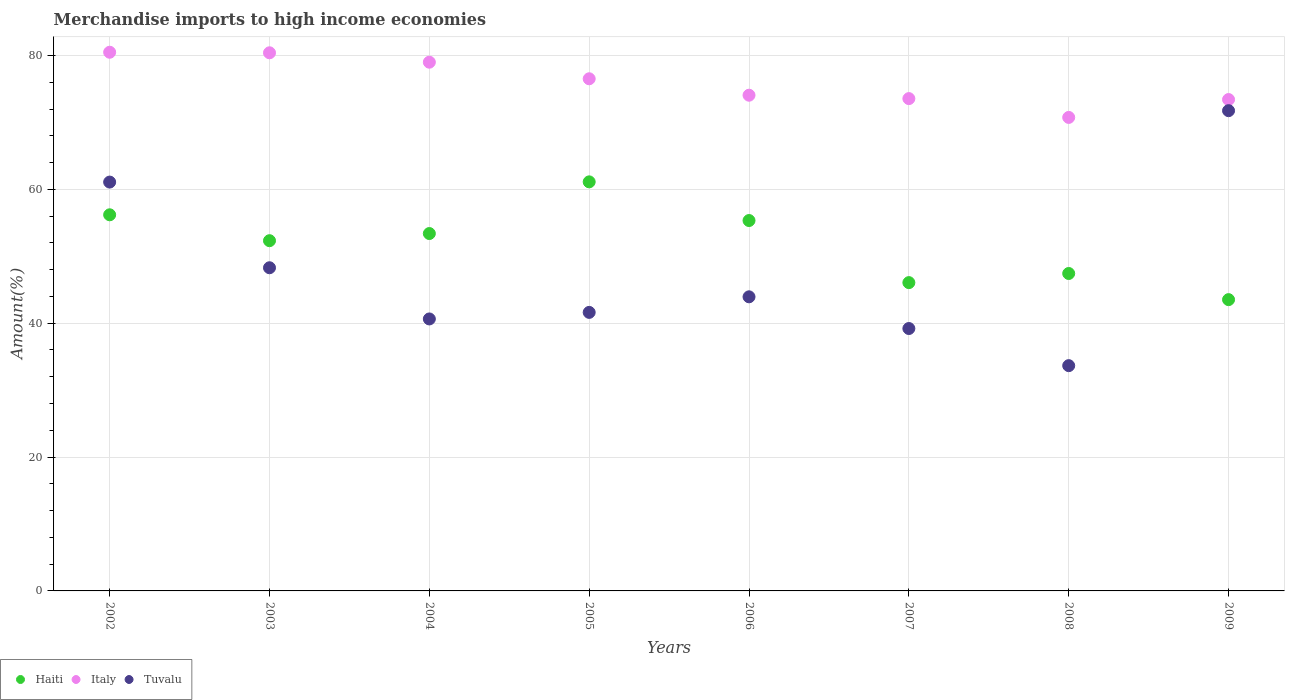What is the percentage of amount earned from merchandise imports in Italy in 2008?
Keep it short and to the point. 70.74. Across all years, what is the maximum percentage of amount earned from merchandise imports in Tuvalu?
Offer a terse response. 71.75. Across all years, what is the minimum percentage of amount earned from merchandise imports in Haiti?
Provide a succinct answer. 43.52. What is the total percentage of amount earned from merchandise imports in Haiti in the graph?
Offer a terse response. 415.37. What is the difference between the percentage of amount earned from merchandise imports in Italy in 2006 and that in 2009?
Your answer should be very brief. 0.65. What is the difference between the percentage of amount earned from merchandise imports in Haiti in 2006 and the percentage of amount earned from merchandise imports in Italy in 2007?
Keep it short and to the point. -18.22. What is the average percentage of amount earned from merchandise imports in Haiti per year?
Your answer should be very brief. 51.92. In the year 2009, what is the difference between the percentage of amount earned from merchandise imports in Tuvalu and percentage of amount earned from merchandise imports in Italy?
Give a very brief answer. -1.67. In how many years, is the percentage of amount earned from merchandise imports in Tuvalu greater than 12 %?
Offer a very short reply. 8. What is the ratio of the percentage of amount earned from merchandise imports in Haiti in 2002 to that in 2004?
Make the answer very short. 1.05. What is the difference between the highest and the second highest percentage of amount earned from merchandise imports in Italy?
Keep it short and to the point. 0.08. What is the difference between the highest and the lowest percentage of amount earned from merchandise imports in Haiti?
Your answer should be very brief. 17.6. In how many years, is the percentage of amount earned from merchandise imports in Italy greater than the average percentage of amount earned from merchandise imports in Italy taken over all years?
Provide a short and direct response. 4. Is it the case that in every year, the sum of the percentage of amount earned from merchandise imports in Haiti and percentage of amount earned from merchandise imports in Tuvalu  is greater than the percentage of amount earned from merchandise imports in Italy?
Keep it short and to the point. Yes. Does the percentage of amount earned from merchandise imports in Haiti monotonically increase over the years?
Your response must be concise. No. Is the percentage of amount earned from merchandise imports in Italy strictly less than the percentage of amount earned from merchandise imports in Tuvalu over the years?
Ensure brevity in your answer.  No. What is the difference between two consecutive major ticks on the Y-axis?
Your response must be concise. 20. Are the values on the major ticks of Y-axis written in scientific E-notation?
Your answer should be compact. No. Does the graph contain any zero values?
Your response must be concise. No. Does the graph contain grids?
Offer a terse response. Yes. Where does the legend appear in the graph?
Your response must be concise. Bottom left. How many legend labels are there?
Your response must be concise. 3. What is the title of the graph?
Your answer should be compact. Merchandise imports to high income economies. What is the label or title of the X-axis?
Ensure brevity in your answer.  Years. What is the label or title of the Y-axis?
Your answer should be very brief. Amount(%). What is the Amount(%) of Haiti in 2002?
Offer a very short reply. 56.19. What is the Amount(%) in Italy in 2002?
Give a very brief answer. 80.48. What is the Amount(%) of Tuvalu in 2002?
Give a very brief answer. 61.08. What is the Amount(%) of Haiti in 2003?
Your response must be concise. 52.32. What is the Amount(%) of Italy in 2003?
Keep it short and to the point. 80.4. What is the Amount(%) in Tuvalu in 2003?
Provide a succinct answer. 48.28. What is the Amount(%) in Haiti in 2004?
Provide a succinct answer. 53.39. What is the Amount(%) in Italy in 2004?
Provide a short and direct response. 78.99. What is the Amount(%) of Tuvalu in 2004?
Make the answer very short. 40.63. What is the Amount(%) of Haiti in 2005?
Provide a short and direct response. 61.12. What is the Amount(%) in Italy in 2005?
Make the answer very short. 76.52. What is the Amount(%) of Tuvalu in 2005?
Keep it short and to the point. 41.61. What is the Amount(%) of Haiti in 2006?
Ensure brevity in your answer.  55.34. What is the Amount(%) in Italy in 2006?
Your answer should be compact. 74.06. What is the Amount(%) of Tuvalu in 2006?
Provide a short and direct response. 43.94. What is the Amount(%) of Haiti in 2007?
Your response must be concise. 46.06. What is the Amount(%) of Italy in 2007?
Keep it short and to the point. 73.55. What is the Amount(%) of Tuvalu in 2007?
Ensure brevity in your answer.  39.2. What is the Amount(%) of Haiti in 2008?
Provide a succinct answer. 47.43. What is the Amount(%) of Italy in 2008?
Keep it short and to the point. 70.74. What is the Amount(%) of Tuvalu in 2008?
Your response must be concise. 33.66. What is the Amount(%) of Haiti in 2009?
Offer a terse response. 43.52. What is the Amount(%) in Italy in 2009?
Provide a succinct answer. 73.41. What is the Amount(%) in Tuvalu in 2009?
Your answer should be compact. 71.75. Across all years, what is the maximum Amount(%) of Haiti?
Offer a terse response. 61.12. Across all years, what is the maximum Amount(%) in Italy?
Ensure brevity in your answer.  80.48. Across all years, what is the maximum Amount(%) in Tuvalu?
Give a very brief answer. 71.75. Across all years, what is the minimum Amount(%) of Haiti?
Make the answer very short. 43.52. Across all years, what is the minimum Amount(%) of Italy?
Keep it short and to the point. 70.74. Across all years, what is the minimum Amount(%) in Tuvalu?
Your response must be concise. 33.66. What is the total Amount(%) in Haiti in the graph?
Make the answer very short. 415.37. What is the total Amount(%) in Italy in the graph?
Keep it short and to the point. 608.16. What is the total Amount(%) of Tuvalu in the graph?
Provide a short and direct response. 380.16. What is the difference between the Amount(%) in Haiti in 2002 and that in 2003?
Keep it short and to the point. 3.87. What is the difference between the Amount(%) in Italy in 2002 and that in 2003?
Make the answer very short. 0.08. What is the difference between the Amount(%) of Tuvalu in 2002 and that in 2003?
Provide a succinct answer. 12.8. What is the difference between the Amount(%) of Haiti in 2002 and that in 2004?
Provide a short and direct response. 2.8. What is the difference between the Amount(%) of Italy in 2002 and that in 2004?
Offer a very short reply. 1.49. What is the difference between the Amount(%) of Tuvalu in 2002 and that in 2004?
Offer a very short reply. 20.45. What is the difference between the Amount(%) in Haiti in 2002 and that in 2005?
Offer a very short reply. -4.92. What is the difference between the Amount(%) of Italy in 2002 and that in 2005?
Ensure brevity in your answer.  3.96. What is the difference between the Amount(%) in Tuvalu in 2002 and that in 2005?
Your response must be concise. 19.47. What is the difference between the Amount(%) of Haiti in 2002 and that in 2006?
Ensure brevity in your answer.  0.86. What is the difference between the Amount(%) of Italy in 2002 and that in 2006?
Your answer should be compact. 6.42. What is the difference between the Amount(%) of Tuvalu in 2002 and that in 2006?
Give a very brief answer. 17.14. What is the difference between the Amount(%) of Haiti in 2002 and that in 2007?
Your answer should be very brief. 10.13. What is the difference between the Amount(%) in Italy in 2002 and that in 2007?
Your answer should be very brief. 6.93. What is the difference between the Amount(%) in Tuvalu in 2002 and that in 2007?
Offer a very short reply. 21.88. What is the difference between the Amount(%) of Haiti in 2002 and that in 2008?
Offer a very short reply. 8.77. What is the difference between the Amount(%) in Italy in 2002 and that in 2008?
Offer a terse response. 9.74. What is the difference between the Amount(%) of Tuvalu in 2002 and that in 2008?
Give a very brief answer. 27.43. What is the difference between the Amount(%) in Haiti in 2002 and that in 2009?
Offer a very short reply. 12.68. What is the difference between the Amount(%) in Italy in 2002 and that in 2009?
Make the answer very short. 7.06. What is the difference between the Amount(%) of Tuvalu in 2002 and that in 2009?
Give a very brief answer. -10.67. What is the difference between the Amount(%) in Haiti in 2003 and that in 2004?
Provide a short and direct response. -1.07. What is the difference between the Amount(%) of Italy in 2003 and that in 2004?
Offer a very short reply. 1.4. What is the difference between the Amount(%) of Tuvalu in 2003 and that in 2004?
Your response must be concise. 7.65. What is the difference between the Amount(%) in Haiti in 2003 and that in 2005?
Make the answer very short. -8.79. What is the difference between the Amount(%) of Italy in 2003 and that in 2005?
Ensure brevity in your answer.  3.88. What is the difference between the Amount(%) in Tuvalu in 2003 and that in 2005?
Keep it short and to the point. 6.67. What is the difference between the Amount(%) in Haiti in 2003 and that in 2006?
Give a very brief answer. -3.01. What is the difference between the Amount(%) of Italy in 2003 and that in 2006?
Your response must be concise. 6.34. What is the difference between the Amount(%) in Tuvalu in 2003 and that in 2006?
Your answer should be compact. 4.34. What is the difference between the Amount(%) of Haiti in 2003 and that in 2007?
Your answer should be compact. 6.26. What is the difference between the Amount(%) of Italy in 2003 and that in 2007?
Offer a very short reply. 6.84. What is the difference between the Amount(%) in Tuvalu in 2003 and that in 2007?
Offer a terse response. 9.08. What is the difference between the Amount(%) in Haiti in 2003 and that in 2008?
Your response must be concise. 4.9. What is the difference between the Amount(%) of Italy in 2003 and that in 2008?
Offer a very short reply. 9.66. What is the difference between the Amount(%) of Tuvalu in 2003 and that in 2008?
Your response must be concise. 14.63. What is the difference between the Amount(%) in Haiti in 2003 and that in 2009?
Keep it short and to the point. 8.81. What is the difference between the Amount(%) of Italy in 2003 and that in 2009?
Provide a short and direct response. 6.98. What is the difference between the Amount(%) in Tuvalu in 2003 and that in 2009?
Ensure brevity in your answer.  -23.47. What is the difference between the Amount(%) of Haiti in 2004 and that in 2005?
Make the answer very short. -7.72. What is the difference between the Amount(%) in Italy in 2004 and that in 2005?
Make the answer very short. 2.48. What is the difference between the Amount(%) of Tuvalu in 2004 and that in 2005?
Provide a short and direct response. -0.98. What is the difference between the Amount(%) of Haiti in 2004 and that in 2006?
Your answer should be compact. -1.94. What is the difference between the Amount(%) of Italy in 2004 and that in 2006?
Give a very brief answer. 4.93. What is the difference between the Amount(%) in Tuvalu in 2004 and that in 2006?
Your response must be concise. -3.31. What is the difference between the Amount(%) of Haiti in 2004 and that in 2007?
Your answer should be compact. 7.33. What is the difference between the Amount(%) in Italy in 2004 and that in 2007?
Give a very brief answer. 5.44. What is the difference between the Amount(%) of Tuvalu in 2004 and that in 2007?
Give a very brief answer. 1.43. What is the difference between the Amount(%) of Haiti in 2004 and that in 2008?
Keep it short and to the point. 5.97. What is the difference between the Amount(%) of Italy in 2004 and that in 2008?
Provide a short and direct response. 8.25. What is the difference between the Amount(%) of Tuvalu in 2004 and that in 2008?
Your response must be concise. 6.98. What is the difference between the Amount(%) of Haiti in 2004 and that in 2009?
Offer a terse response. 9.88. What is the difference between the Amount(%) of Italy in 2004 and that in 2009?
Offer a terse response. 5.58. What is the difference between the Amount(%) of Tuvalu in 2004 and that in 2009?
Offer a very short reply. -31.11. What is the difference between the Amount(%) in Haiti in 2005 and that in 2006?
Give a very brief answer. 5.78. What is the difference between the Amount(%) in Italy in 2005 and that in 2006?
Your answer should be very brief. 2.45. What is the difference between the Amount(%) in Tuvalu in 2005 and that in 2006?
Your answer should be compact. -2.33. What is the difference between the Amount(%) in Haiti in 2005 and that in 2007?
Offer a very short reply. 15.05. What is the difference between the Amount(%) of Italy in 2005 and that in 2007?
Provide a succinct answer. 2.96. What is the difference between the Amount(%) of Tuvalu in 2005 and that in 2007?
Offer a very short reply. 2.41. What is the difference between the Amount(%) of Haiti in 2005 and that in 2008?
Your answer should be very brief. 13.69. What is the difference between the Amount(%) of Italy in 2005 and that in 2008?
Your answer should be very brief. 5.77. What is the difference between the Amount(%) of Tuvalu in 2005 and that in 2008?
Your answer should be compact. 7.96. What is the difference between the Amount(%) of Haiti in 2005 and that in 2009?
Your response must be concise. 17.6. What is the difference between the Amount(%) of Italy in 2005 and that in 2009?
Your answer should be compact. 3.1. What is the difference between the Amount(%) of Tuvalu in 2005 and that in 2009?
Your answer should be very brief. -30.14. What is the difference between the Amount(%) of Haiti in 2006 and that in 2007?
Give a very brief answer. 9.28. What is the difference between the Amount(%) in Italy in 2006 and that in 2007?
Provide a succinct answer. 0.51. What is the difference between the Amount(%) in Tuvalu in 2006 and that in 2007?
Offer a very short reply. 4.74. What is the difference between the Amount(%) of Haiti in 2006 and that in 2008?
Ensure brevity in your answer.  7.91. What is the difference between the Amount(%) in Italy in 2006 and that in 2008?
Ensure brevity in your answer.  3.32. What is the difference between the Amount(%) of Tuvalu in 2006 and that in 2008?
Provide a succinct answer. 10.28. What is the difference between the Amount(%) in Haiti in 2006 and that in 2009?
Your response must be concise. 11.82. What is the difference between the Amount(%) in Italy in 2006 and that in 2009?
Make the answer very short. 0.65. What is the difference between the Amount(%) of Tuvalu in 2006 and that in 2009?
Your answer should be very brief. -27.81. What is the difference between the Amount(%) in Haiti in 2007 and that in 2008?
Keep it short and to the point. -1.36. What is the difference between the Amount(%) in Italy in 2007 and that in 2008?
Provide a succinct answer. 2.81. What is the difference between the Amount(%) of Tuvalu in 2007 and that in 2008?
Give a very brief answer. 5.55. What is the difference between the Amount(%) of Haiti in 2007 and that in 2009?
Give a very brief answer. 2.54. What is the difference between the Amount(%) in Italy in 2007 and that in 2009?
Your answer should be compact. 0.14. What is the difference between the Amount(%) of Tuvalu in 2007 and that in 2009?
Provide a succinct answer. -32.55. What is the difference between the Amount(%) of Haiti in 2008 and that in 2009?
Offer a terse response. 3.91. What is the difference between the Amount(%) of Italy in 2008 and that in 2009?
Your answer should be very brief. -2.67. What is the difference between the Amount(%) of Tuvalu in 2008 and that in 2009?
Provide a succinct answer. -38.09. What is the difference between the Amount(%) of Haiti in 2002 and the Amount(%) of Italy in 2003?
Ensure brevity in your answer.  -24.2. What is the difference between the Amount(%) in Haiti in 2002 and the Amount(%) in Tuvalu in 2003?
Provide a succinct answer. 7.91. What is the difference between the Amount(%) in Italy in 2002 and the Amount(%) in Tuvalu in 2003?
Give a very brief answer. 32.2. What is the difference between the Amount(%) of Haiti in 2002 and the Amount(%) of Italy in 2004?
Your response must be concise. -22.8. What is the difference between the Amount(%) in Haiti in 2002 and the Amount(%) in Tuvalu in 2004?
Ensure brevity in your answer.  15.56. What is the difference between the Amount(%) of Italy in 2002 and the Amount(%) of Tuvalu in 2004?
Make the answer very short. 39.85. What is the difference between the Amount(%) in Haiti in 2002 and the Amount(%) in Italy in 2005?
Your response must be concise. -20.32. What is the difference between the Amount(%) of Haiti in 2002 and the Amount(%) of Tuvalu in 2005?
Provide a succinct answer. 14.58. What is the difference between the Amount(%) of Italy in 2002 and the Amount(%) of Tuvalu in 2005?
Your answer should be compact. 38.87. What is the difference between the Amount(%) in Haiti in 2002 and the Amount(%) in Italy in 2006?
Your answer should be compact. -17.87. What is the difference between the Amount(%) in Haiti in 2002 and the Amount(%) in Tuvalu in 2006?
Your response must be concise. 12.25. What is the difference between the Amount(%) of Italy in 2002 and the Amount(%) of Tuvalu in 2006?
Your answer should be compact. 36.54. What is the difference between the Amount(%) in Haiti in 2002 and the Amount(%) in Italy in 2007?
Your response must be concise. -17.36. What is the difference between the Amount(%) in Haiti in 2002 and the Amount(%) in Tuvalu in 2007?
Your answer should be compact. 16.99. What is the difference between the Amount(%) of Italy in 2002 and the Amount(%) of Tuvalu in 2007?
Your response must be concise. 41.28. What is the difference between the Amount(%) in Haiti in 2002 and the Amount(%) in Italy in 2008?
Your answer should be very brief. -14.55. What is the difference between the Amount(%) in Haiti in 2002 and the Amount(%) in Tuvalu in 2008?
Your response must be concise. 22.54. What is the difference between the Amount(%) in Italy in 2002 and the Amount(%) in Tuvalu in 2008?
Ensure brevity in your answer.  46.82. What is the difference between the Amount(%) of Haiti in 2002 and the Amount(%) of Italy in 2009?
Offer a terse response. -17.22. What is the difference between the Amount(%) in Haiti in 2002 and the Amount(%) in Tuvalu in 2009?
Your answer should be very brief. -15.56. What is the difference between the Amount(%) in Italy in 2002 and the Amount(%) in Tuvalu in 2009?
Provide a succinct answer. 8.73. What is the difference between the Amount(%) in Haiti in 2003 and the Amount(%) in Italy in 2004?
Give a very brief answer. -26.67. What is the difference between the Amount(%) in Haiti in 2003 and the Amount(%) in Tuvalu in 2004?
Give a very brief answer. 11.69. What is the difference between the Amount(%) in Italy in 2003 and the Amount(%) in Tuvalu in 2004?
Provide a succinct answer. 39.76. What is the difference between the Amount(%) of Haiti in 2003 and the Amount(%) of Italy in 2005?
Keep it short and to the point. -24.19. What is the difference between the Amount(%) of Haiti in 2003 and the Amount(%) of Tuvalu in 2005?
Give a very brief answer. 10.71. What is the difference between the Amount(%) in Italy in 2003 and the Amount(%) in Tuvalu in 2005?
Ensure brevity in your answer.  38.78. What is the difference between the Amount(%) in Haiti in 2003 and the Amount(%) in Italy in 2006?
Ensure brevity in your answer.  -21.74. What is the difference between the Amount(%) of Haiti in 2003 and the Amount(%) of Tuvalu in 2006?
Your response must be concise. 8.39. What is the difference between the Amount(%) of Italy in 2003 and the Amount(%) of Tuvalu in 2006?
Your response must be concise. 36.46. What is the difference between the Amount(%) of Haiti in 2003 and the Amount(%) of Italy in 2007?
Provide a short and direct response. -21.23. What is the difference between the Amount(%) of Haiti in 2003 and the Amount(%) of Tuvalu in 2007?
Offer a terse response. 13.12. What is the difference between the Amount(%) in Italy in 2003 and the Amount(%) in Tuvalu in 2007?
Offer a terse response. 41.19. What is the difference between the Amount(%) in Haiti in 2003 and the Amount(%) in Italy in 2008?
Your response must be concise. -18.42. What is the difference between the Amount(%) of Haiti in 2003 and the Amount(%) of Tuvalu in 2008?
Provide a short and direct response. 18.67. What is the difference between the Amount(%) of Italy in 2003 and the Amount(%) of Tuvalu in 2008?
Offer a terse response. 46.74. What is the difference between the Amount(%) of Haiti in 2003 and the Amount(%) of Italy in 2009?
Make the answer very short. -21.09. What is the difference between the Amount(%) of Haiti in 2003 and the Amount(%) of Tuvalu in 2009?
Your response must be concise. -19.42. What is the difference between the Amount(%) in Italy in 2003 and the Amount(%) in Tuvalu in 2009?
Keep it short and to the point. 8.65. What is the difference between the Amount(%) of Haiti in 2004 and the Amount(%) of Italy in 2005?
Your answer should be compact. -23.12. What is the difference between the Amount(%) in Haiti in 2004 and the Amount(%) in Tuvalu in 2005?
Provide a succinct answer. 11.78. What is the difference between the Amount(%) in Italy in 2004 and the Amount(%) in Tuvalu in 2005?
Offer a very short reply. 37.38. What is the difference between the Amount(%) in Haiti in 2004 and the Amount(%) in Italy in 2006?
Offer a very short reply. -20.67. What is the difference between the Amount(%) in Haiti in 2004 and the Amount(%) in Tuvalu in 2006?
Make the answer very short. 9.45. What is the difference between the Amount(%) in Italy in 2004 and the Amount(%) in Tuvalu in 2006?
Provide a short and direct response. 35.05. What is the difference between the Amount(%) of Haiti in 2004 and the Amount(%) of Italy in 2007?
Ensure brevity in your answer.  -20.16. What is the difference between the Amount(%) in Haiti in 2004 and the Amount(%) in Tuvalu in 2007?
Provide a succinct answer. 14.19. What is the difference between the Amount(%) of Italy in 2004 and the Amount(%) of Tuvalu in 2007?
Give a very brief answer. 39.79. What is the difference between the Amount(%) of Haiti in 2004 and the Amount(%) of Italy in 2008?
Ensure brevity in your answer.  -17.35. What is the difference between the Amount(%) of Haiti in 2004 and the Amount(%) of Tuvalu in 2008?
Your response must be concise. 19.74. What is the difference between the Amount(%) in Italy in 2004 and the Amount(%) in Tuvalu in 2008?
Offer a terse response. 45.34. What is the difference between the Amount(%) of Haiti in 2004 and the Amount(%) of Italy in 2009?
Provide a short and direct response. -20.02. What is the difference between the Amount(%) in Haiti in 2004 and the Amount(%) in Tuvalu in 2009?
Provide a succinct answer. -18.36. What is the difference between the Amount(%) of Italy in 2004 and the Amount(%) of Tuvalu in 2009?
Make the answer very short. 7.24. What is the difference between the Amount(%) of Haiti in 2005 and the Amount(%) of Italy in 2006?
Provide a short and direct response. -12.95. What is the difference between the Amount(%) of Haiti in 2005 and the Amount(%) of Tuvalu in 2006?
Your answer should be compact. 17.18. What is the difference between the Amount(%) in Italy in 2005 and the Amount(%) in Tuvalu in 2006?
Make the answer very short. 32.58. What is the difference between the Amount(%) of Haiti in 2005 and the Amount(%) of Italy in 2007?
Provide a short and direct response. -12.44. What is the difference between the Amount(%) in Haiti in 2005 and the Amount(%) in Tuvalu in 2007?
Provide a short and direct response. 21.91. What is the difference between the Amount(%) in Italy in 2005 and the Amount(%) in Tuvalu in 2007?
Offer a very short reply. 37.31. What is the difference between the Amount(%) of Haiti in 2005 and the Amount(%) of Italy in 2008?
Your answer should be very brief. -9.63. What is the difference between the Amount(%) in Haiti in 2005 and the Amount(%) in Tuvalu in 2008?
Your answer should be compact. 27.46. What is the difference between the Amount(%) in Italy in 2005 and the Amount(%) in Tuvalu in 2008?
Make the answer very short. 42.86. What is the difference between the Amount(%) of Haiti in 2005 and the Amount(%) of Italy in 2009?
Keep it short and to the point. -12.3. What is the difference between the Amount(%) in Haiti in 2005 and the Amount(%) in Tuvalu in 2009?
Give a very brief answer. -10.63. What is the difference between the Amount(%) in Italy in 2005 and the Amount(%) in Tuvalu in 2009?
Keep it short and to the point. 4.77. What is the difference between the Amount(%) in Haiti in 2006 and the Amount(%) in Italy in 2007?
Your answer should be very brief. -18.22. What is the difference between the Amount(%) of Haiti in 2006 and the Amount(%) of Tuvalu in 2007?
Your answer should be very brief. 16.13. What is the difference between the Amount(%) of Italy in 2006 and the Amount(%) of Tuvalu in 2007?
Keep it short and to the point. 34.86. What is the difference between the Amount(%) of Haiti in 2006 and the Amount(%) of Italy in 2008?
Make the answer very short. -15.41. What is the difference between the Amount(%) in Haiti in 2006 and the Amount(%) in Tuvalu in 2008?
Your response must be concise. 21.68. What is the difference between the Amount(%) in Italy in 2006 and the Amount(%) in Tuvalu in 2008?
Make the answer very short. 40.4. What is the difference between the Amount(%) of Haiti in 2006 and the Amount(%) of Italy in 2009?
Keep it short and to the point. -18.08. What is the difference between the Amount(%) in Haiti in 2006 and the Amount(%) in Tuvalu in 2009?
Your response must be concise. -16.41. What is the difference between the Amount(%) in Italy in 2006 and the Amount(%) in Tuvalu in 2009?
Your answer should be compact. 2.31. What is the difference between the Amount(%) of Haiti in 2007 and the Amount(%) of Italy in 2008?
Give a very brief answer. -24.68. What is the difference between the Amount(%) in Haiti in 2007 and the Amount(%) in Tuvalu in 2008?
Make the answer very short. 12.41. What is the difference between the Amount(%) in Italy in 2007 and the Amount(%) in Tuvalu in 2008?
Your answer should be compact. 39.9. What is the difference between the Amount(%) of Haiti in 2007 and the Amount(%) of Italy in 2009?
Offer a very short reply. -27.35. What is the difference between the Amount(%) in Haiti in 2007 and the Amount(%) in Tuvalu in 2009?
Offer a very short reply. -25.69. What is the difference between the Amount(%) in Italy in 2007 and the Amount(%) in Tuvalu in 2009?
Provide a succinct answer. 1.8. What is the difference between the Amount(%) of Haiti in 2008 and the Amount(%) of Italy in 2009?
Your answer should be very brief. -25.99. What is the difference between the Amount(%) in Haiti in 2008 and the Amount(%) in Tuvalu in 2009?
Your answer should be compact. -24.32. What is the difference between the Amount(%) of Italy in 2008 and the Amount(%) of Tuvalu in 2009?
Ensure brevity in your answer.  -1.01. What is the average Amount(%) in Haiti per year?
Make the answer very short. 51.92. What is the average Amount(%) in Italy per year?
Ensure brevity in your answer.  76.02. What is the average Amount(%) of Tuvalu per year?
Ensure brevity in your answer.  47.52. In the year 2002, what is the difference between the Amount(%) in Haiti and Amount(%) in Italy?
Provide a succinct answer. -24.29. In the year 2002, what is the difference between the Amount(%) in Haiti and Amount(%) in Tuvalu?
Offer a very short reply. -4.89. In the year 2002, what is the difference between the Amount(%) of Italy and Amount(%) of Tuvalu?
Give a very brief answer. 19.4. In the year 2003, what is the difference between the Amount(%) of Haiti and Amount(%) of Italy?
Ensure brevity in your answer.  -28.07. In the year 2003, what is the difference between the Amount(%) of Haiti and Amount(%) of Tuvalu?
Your answer should be very brief. 4.04. In the year 2003, what is the difference between the Amount(%) of Italy and Amount(%) of Tuvalu?
Offer a very short reply. 32.12. In the year 2004, what is the difference between the Amount(%) of Haiti and Amount(%) of Italy?
Make the answer very short. -25.6. In the year 2004, what is the difference between the Amount(%) in Haiti and Amount(%) in Tuvalu?
Your answer should be very brief. 12.76. In the year 2004, what is the difference between the Amount(%) in Italy and Amount(%) in Tuvalu?
Give a very brief answer. 38.36. In the year 2005, what is the difference between the Amount(%) of Haiti and Amount(%) of Italy?
Your response must be concise. -15.4. In the year 2005, what is the difference between the Amount(%) in Haiti and Amount(%) in Tuvalu?
Give a very brief answer. 19.5. In the year 2005, what is the difference between the Amount(%) of Italy and Amount(%) of Tuvalu?
Offer a very short reply. 34.9. In the year 2006, what is the difference between the Amount(%) in Haiti and Amount(%) in Italy?
Your answer should be very brief. -18.72. In the year 2006, what is the difference between the Amount(%) in Haiti and Amount(%) in Tuvalu?
Your response must be concise. 11.4. In the year 2006, what is the difference between the Amount(%) of Italy and Amount(%) of Tuvalu?
Make the answer very short. 30.12. In the year 2007, what is the difference between the Amount(%) of Haiti and Amount(%) of Italy?
Make the answer very short. -27.49. In the year 2007, what is the difference between the Amount(%) of Haiti and Amount(%) of Tuvalu?
Provide a short and direct response. 6.86. In the year 2007, what is the difference between the Amount(%) of Italy and Amount(%) of Tuvalu?
Give a very brief answer. 34.35. In the year 2008, what is the difference between the Amount(%) of Haiti and Amount(%) of Italy?
Keep it short and to the point. -23.32. In the year 2008, what is the difference between the Amount(%) of Haiti and Amount(%) of Tuvalu?
Offer a terse response. 13.77. In the year 2008, what is the difference between the Amount(%) in Italy and Amount(%) in Tuvalu?
Offer a terse response. 37.09. In the year 2009, what is the difference between the Amount(%) of Haiti and Amount(%) of Italy?
Offer a very short reply. -29.9. In the year 2009, what is the difference between the Amount(%) in Haiti and Amount(%) in Tuvalu?
Provide a short and direct response. -28.23. In the year 2009, what is the difference between the Amount(%) of Italy and Amount(%) of Tuvalu?
Make the answer very short. 1.67. What is the ratio of the Amount(%) of Haiti in 2002 to that in 2003?
Ensure brevity in your answer.  1.07. What is the ratio of the Amount(%) in Tuvalu in 2002 to that in 2003?
Keep it short and to the point. 1.27. What is the ratio of the Amount(%) of Haiti in 2002 to that in 2004?
Give a very brief answer. 1.05. What is the ratio of the Amount(%) of Italy in 2002 to that in 2004?
Your answer should be compact. 1.02. What is the ratio of the Amount(%) in Tuvalu in 2002 to that in 2004?
Keep it short and to the point. 1.5. What is the ratio of the Amount(%) of Haiti in 2002 to that in 2005?
Offer a terse response. 0.92. What is the ratio of the Amount(%) in Italy in 2002 to that in 2005?
Provide a succinct answer. 1.05. What is the ratio of the Amount(%) in Tuvalu in 2002 to that in 2005?
Offer a very short reply. 1.47. What is the ratio of the Amount(%) in Haiti in 2002 to that in 2006?
Give a very brief answer. 1.02. What is the ratio of the Amount(%) of Italy in 2002 to that in 2006?
Ensure brevity in your answer.  1.09. What is the ratio of the Amount(%) in Tuvalu in 2002 to that in 2006?
Make the answer very short. 1.39. What is the ratio of the Amount(%) of Haiti in 2002 to that in 2007?
Your response must be concise. 1.22. What is the ratio of the Amount(%) in Italy in 2002 to that in 2007?
Keep it short and to the point. 1.09. What is the ratio of the Amount(%) in Tuvalu in 2002 to that in 2007?
Provide a succinct answer. 1.56. What is the ratio of the Amount(%) in Haiti in 2002 to that in 2008?
Provide a succinct answer. 1.18. What is the ratio of the Amount(%) in Italy in 2002 to that in 2008?
Your answer should be compact. 1.14. What is the ratio of the Amount(%) in Tuvalu in 2002 to that in 2008?
Your answer should be very brief. 1.81. What is the ratio of the Amount(%) of Haiti in 2002 to that in 2009?
Make the answer very short. 1.29. What is the ratio of the Amount(%) in Italy in 2002 to that in 2009?
Keep it short and to the point. 1.1. What is the ratio of the Amount(%) of Tuvalu in 2002 to that in 2009?
Ensure brevity in your answer.  0.85. What is the ratio of the Amount(%) of Haiti in 2003 to that in 2004?
Provide a succinct answer. 0.98. What is the ratio of the Amount(%) of Italy in 2003 to that in 2004?
Your answer should be compact. 1.02. What is the ratio of the Amount(%) of Tuvalu in 2003 to that in 2004?
Provide a short and direct response. 1.19. What is the ratio of the Amount(%) of Haiti in 2003 to that in 2005?
Provide a succinct answer. 0.86. What is the ratio of the Amount(%) in Italy in 2003 to that in 2005?
Make the answer very short. 1.05. What is the ratio of the Amount(%) of Tuvalu in 2003 to that in 2005?
Your answer should be compact. 1.16. What is the ratio of the Amount(%) in Haiti in 2003 to that in 2006?
Give a very brief answer. 0.95. What is the ratio of the Amount(%) of Italy in 2003 to that in 2006?
Offer a terse response. 1.09. What is the ratio of the Amount(%) in Tuvalu in 2003 to that in 2006?
Give a very brief answer. 1.1. What is the ratio of the Amount(%) in Haiti in 2003 to that in 2007?
Provide a succinct answer. 1.14. What is the ratio of the Amount(%) of Italy in 2003 to that in 2007?
Keep it short and to the point. 1.09. What is the ratio of the Amount(%) in Tuvalu in 2003 to that in 2007?
Keep it short and to the point. 1.23. What is the ratio of the Amount(%) of Haiti in 2003 to that in 2008?
Your answer should be very brief. 1.1. What is the ratio of the Amount(%) of Italy in 2003 to that in 2008?
Give a very brief answer. 1.14. What is the ratio of the Amount(%) in Tuvalu in 2003 to that in 2008?
Ensure brevity in your answer.  1.43. What is the ratio of the Amount(%) in Haiti in 2003 to that in 2009?
Give a very brief answer. 1.2. What is the ratio of the Amount(%) in Italy in 2003 to that in 2009?
Provide a succinct answer. 1.1. What is the ratio of the Amount(%) of Tuvalu in 2003 to that in 2009?
Give a very brief answer. 0.67. What is the ratio of the Amount(%) in Haiti in 2004 to that in 2005?
Provide a short and direct response. 0.87. What is the ratio of the Amount(%) of Italy in 2004 to that in 2005?
Your response must be concise. 1.03. What is the ratio of the Amount(%) in Tuvalu in 2004 to that in 2005?
Offer a terse response. 0.98. What is the ratio of the Amount(%) in Haiti in 2004 to that in 2006?
Provide a succinct answer. 0.96. What is the ratio of the Amount(%) of Italy in 2004 to that in 2006?
Keep it short and to the point. 1.07. What is the ratio of the Amount(%) of Tuvalu in 2004 to that in 2006?
Make the answer very short. 0.92. What is the ratio of the Amount(%) of Haiti in 2004 to that in 2007?
Offer a very short reply. 1.16. What is the ratio of the Amount(%) in Italy in 2004 to that in 2007?
Make the answer very short. 1.07. What is the ratio of the Amount(%) in Tuvalu in 2004 to that in 2007?
Provide a succinct answer. 1.04. What is the ratio of the Amount(%) in Haiti in 2004 to that in 2008?
Your answer should be very brief. 1.13. What is the ratio of the Amount(%) of Italy in 2004 to that in 2008?
Provide a succinct answer. 1.12. What is the ratio of the Amount(%) of Tuvalu in 2004 to that in 2008?
Make the answer very short. 1.21. What is the ratio of the Amount(%) of Haiti in 2004 to that in 2009?
Offer a very short reply. 1.23. What is the ratio of the Amount(%) in Italy in 2004 to that in 2009?
Make the answer very short. 1.08. What is the ratio of the Amount(%) of Tuvalu in 2004 to that in 2009?
Keep it short and to the point. 0.57. What is the ratio of the Amount(%) of Haiti in 2005 to that in 2006?
Your response must be concise. 1.1. What is the ratio of the Amount(%) in Italy in 2005 to that in 2006?
Provide a succinct answer. 1.03. What is the ratio of the Amount(%) in Tuvalu in 2005 to that in 2006?
Your answer should be compact. 0.95. What is the ratio of the Amount(%) of Haiti in 2005 to that in 2007?
Your answer should be compact. 1.33. What is the ratio of the Amount(%) in Italy in 2005 to that in 2007?
Provide a succinct answer. 1.04. What is the ratio of the Amount(%) of Tuvalu in 2005 to that in 2007?
Offer a terse response. 1.06. What is the ratio of the Amount(%) in Haiti in 2005 to that in 2008?
Make the answer very short. 1.29. What is the ratio of the Amount(%) of Italy in 2005 to that in 2008?
Your response must be concise. 1.08. What is the ratio of the Amount(%) in Tuvalu in 2005 to that in 2008?
Keep it short and to the point. 1.24. What is the ratio of the Amount(%) in Haiti in 2005 to that in 2009?
Provide a succinct answer. 1.4. What is the ratio of the Amount(%) in Italy in 2005 to that in 2009?
Your answer should be very brief. 1.04. What is the ratio of the Amount(%) of Tuvalu in 2005 to that in 2009?
Your response must be concise. 0.58. What is the ratio of the Amount(%) in Haiti in 2006 to that in 2007?
Give a very brief answer. 1.2. What is the ratio of the Amount(%) of Tuvalu in 2006 to that in 2007?
Make the answer very short. 1.12. What is the ratio of the Amount(%) in Haiti in 2006 to that in 2008?
Ensure brevity in your answer.  1.17. What is the ratio of the Amount(%) in Italy in 2006 to that in 2008?
Offer a terse response. 1.05. What is the ratio of the Amount(%) of Tuvalu in 2006 to that in 2008?
Provide a short and direct response. 1.31. What is the ratio of the Amount(%) in Haiti in 2006 to that in 2009?
Your answer should be compact. 1.27. What is the ratio of the Amount(%) of Italy in 2006 to that in 2009?
Keep it short and to the point. 1.01. What is the ratio of the Amount(%) of Tuvalu in 2006 to that in 2009?
Your response must be concise. 0.61. What is the ratio of the Amount(%) of Haiti in 2007 to that in 2008?
Keep it short and to the point. 0.97. What is the ratio of the Amount(%) in Italy in 2007 to that in 2008?
Offer a terse response. 1.04. What is the ratio of the Amount(%) in Tuvalu in 2007 to that in 2008?
Provide a short and direct response. 1.16. What is the ratio of the Amount(%) of Haiti in 2007 to that in 2009?
Offer a terse response. 1.06. What is the ratio of the Amount(%) of Tuvalu in 2007 to that in 2009?
Your response must be concise. 0.55. What is the ratio of the Amount(%) of Haiti in 2008 to that in 2009?
Keep it short and to the point. 1.09. What is the ratio of the Amount(%) in Italy in 2008 to that in 2009?
Give a very brief answer. 0.96. What is the ratio of the Amount(%) of Tuvalu in 2008 to that in 2009?
Ensure brevity in your answer.  0.47. What is the difference between the highest and the second highest Amount(%) in Haiti?
Your answer should be very brief. 4.92. What is the difference between the highest and the second highest Amount(%) of Italy?
Your answer should be very brief. 0.08. What is the difference between the highest and the second highest Amount(%) of Tuvalu?
Give a very brief answer. 10.67. What is the difference between the highest and the lowest Amount(%) in Haiti?
Make the answer very short. 17.6. What is the difference between the highest and the lowest Amount(%) of Italy?
Ensure brevity in your answer.  9.74. What is the difference between the highest and the lowest Amount(%) in Tuvalu?
Make the answer very short. 38.09. 